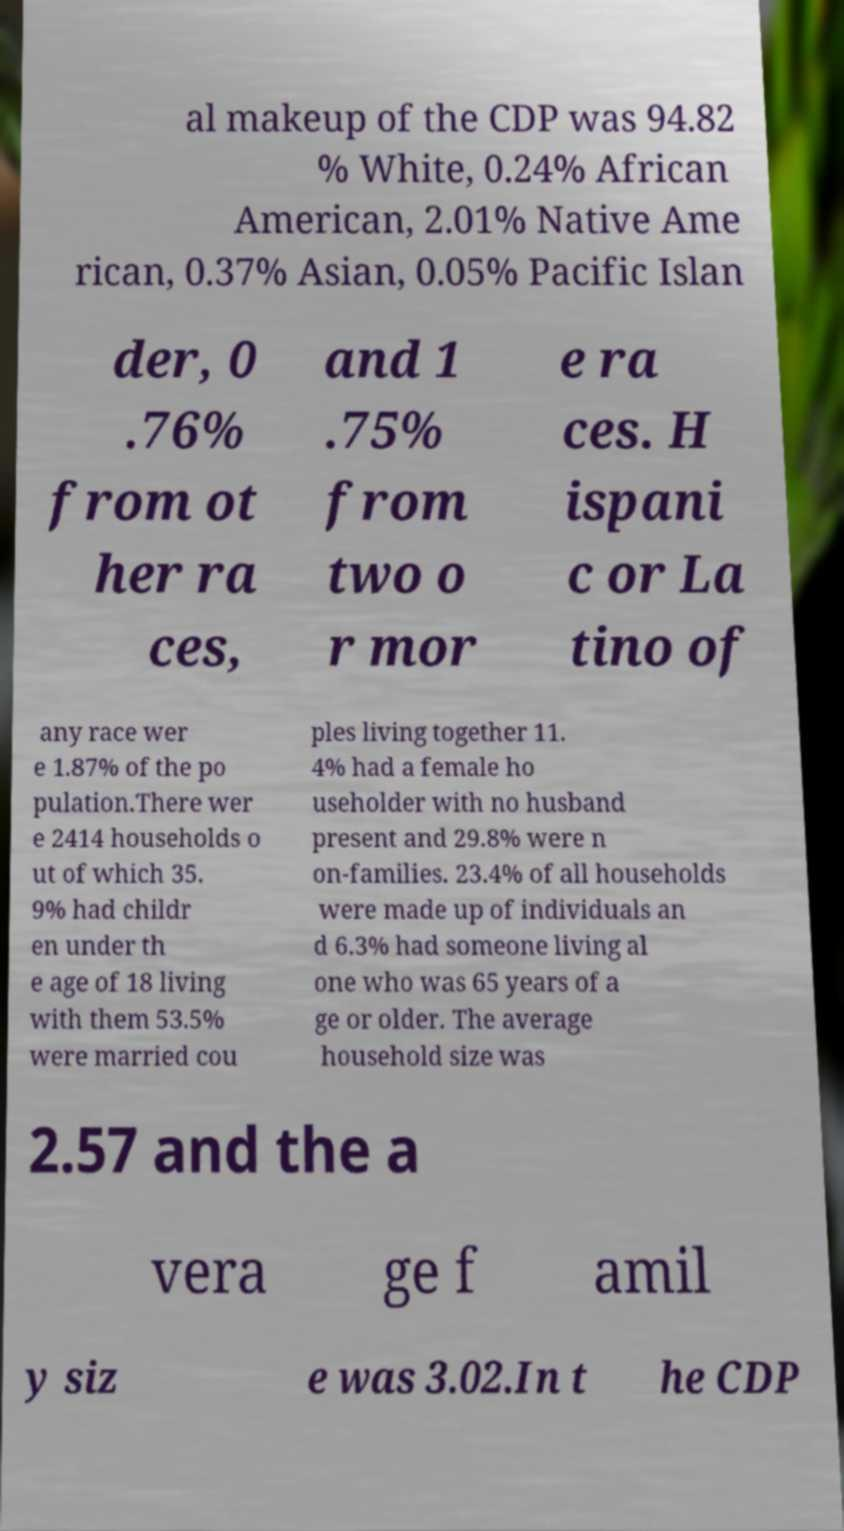What messages or text are displayed in this image? I need them in a readable, typed format. al makeup of the CDP was 94.82 % White, 0.24% African American, 2.01% Native Ame rican, 0.37% Asian, 0.05% Pacific Islan der, 0 .76% from ot her ra ces, and 1 .75% from two o r mor e ra ces. H ispani c or La tino of any race wer e 1.87% of the po pulation.There wer e 2414 households o ut of which 35. 9% had childr en under th e age of 18 living with them 53.5% were married cou ples living together 11. 4% had a female ho useholder with no husband present and 29.8% were n on-families. 23.4% of all households were made up of individuals an d 6.3% had someone living al one who was 65 years of a ge or older. The average household size was 2.57 and the a vera ge f amil y siz e was 3.02.In t he CDP 